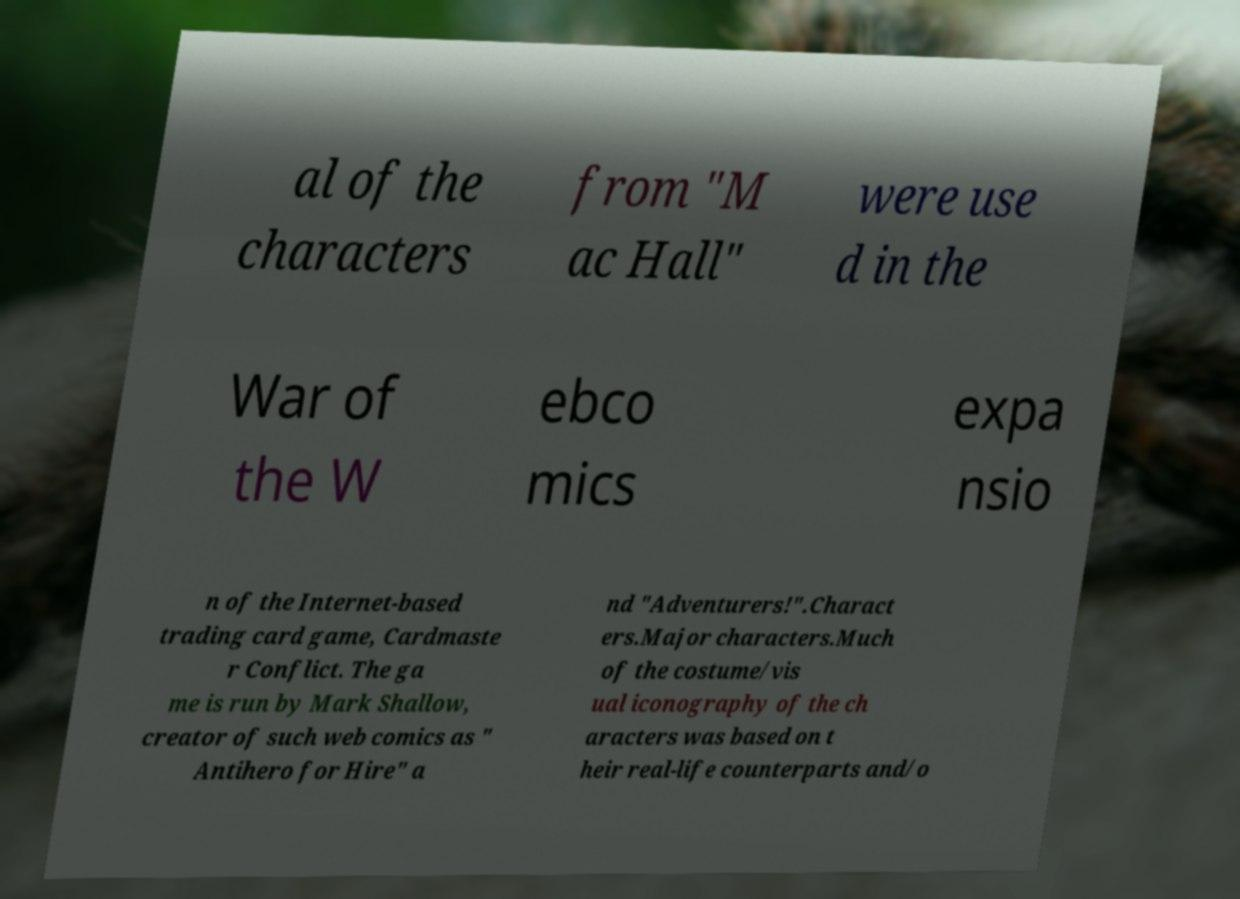There's text embedded in this image that I need extracted. Can you transcribe it verbatim? al of the characters from "M ac Hall" were use d in the War of the W ebco mics expa nsio n of the Internet-based trading card game, Cardmaste r Conflict. The ga me is run by Mark Shallow, creator of such web comics as " Antihero for Hire" a nd "Adventurers!".Charact ers.Major characters.Much of the costume/vis ual iconography of the ch aracters was based on t heir real-life counterparts and/o 